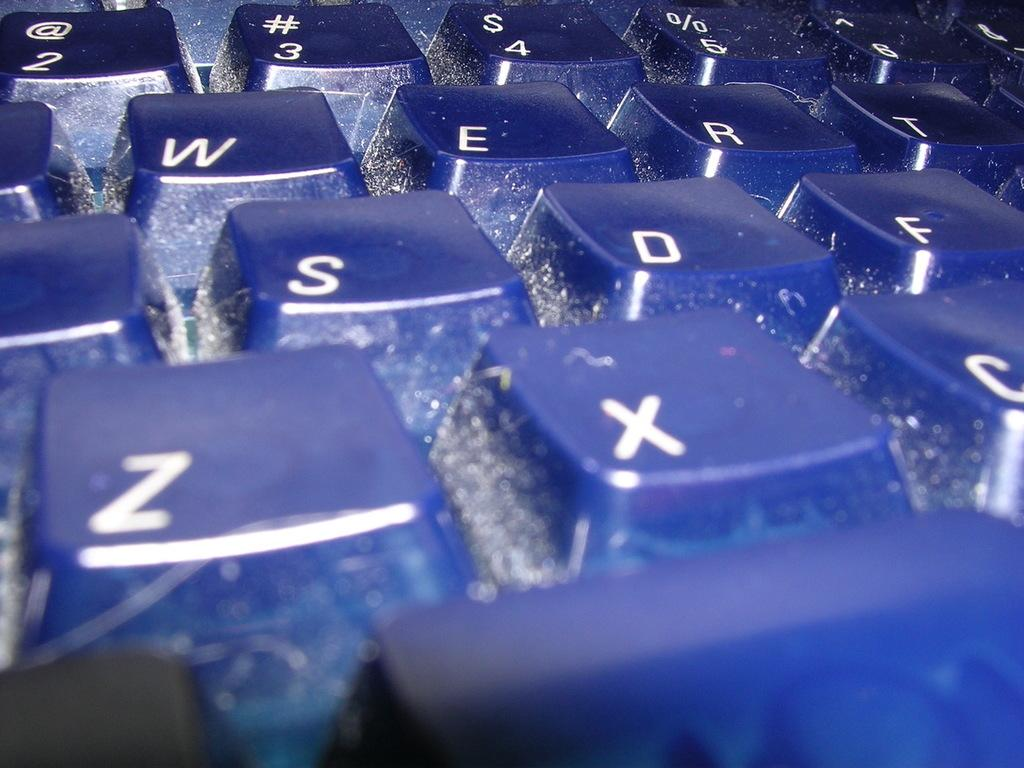<image>
Describe the image concisely. A close up of a partial computer keyboard shows the keys W E S D Z X. 